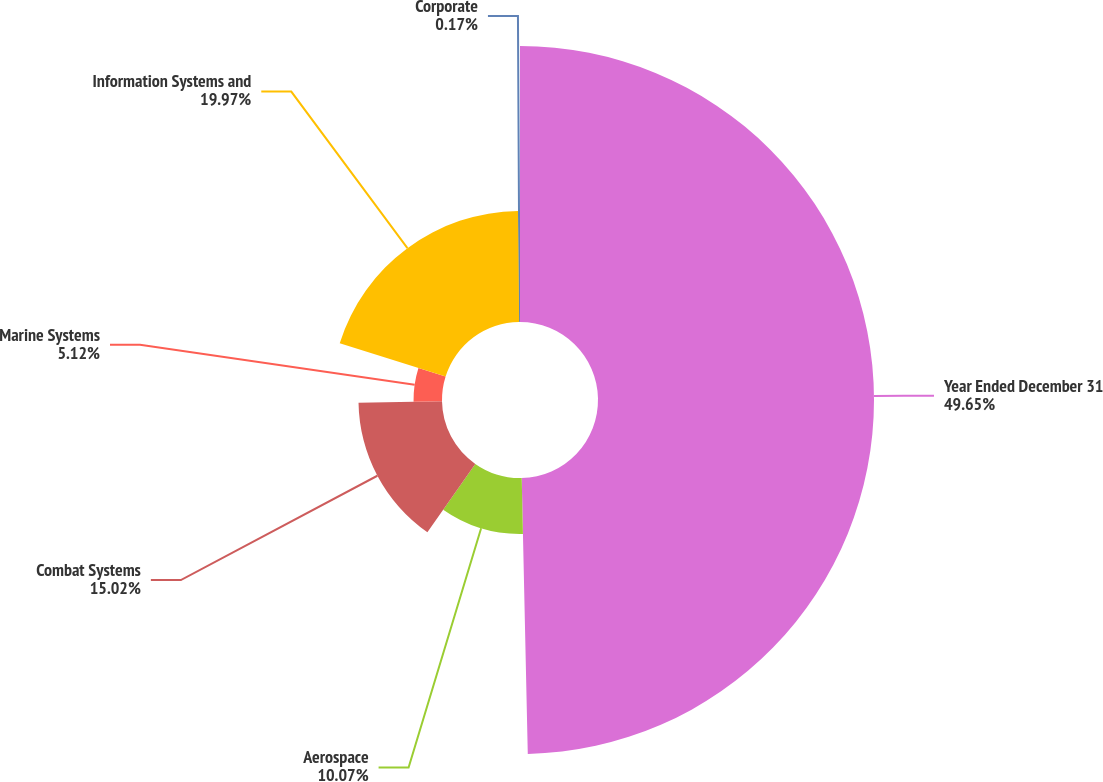Convert chart to OTSL. <chart><loc_0><loc_0><loc_500><loc_500><pie_chart><fcel>Year Ended December 31<fcel>Aerospace<fcel>Combat Systems<fcel>Marine Systems<fcel>Information Systems and<fcel>Corporate<nl><fcel>49.65%<fcel>10.07%<fcel>15.02%<fcel>5.12%<fcel>19.97%<fcel>0.17%<nl></chart> 